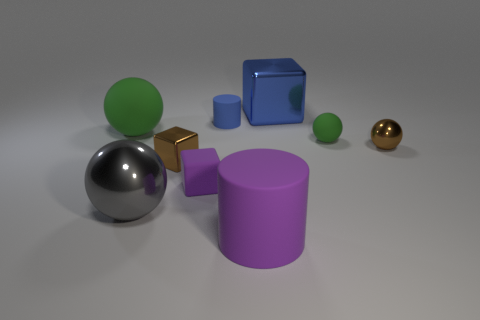Subtract all small rubber blocks. How many blocks are left? 2 Subtract all gray balls. How many balls are left? 3 Subtract 1 cylinders. How many cylinders are left? 1 Subtract all cylinders. How many objects are left? 7 Add 9 tiny matte cubes. How many tiny matte cubes exist? 10 Subtract 2 green spheres. How many objects are left? 7 Subtract all purple balls. Subtract all brown cubes. How many balls are left? 4 Subtract all cyan cubes. How many red spheres are left? 0 Subtract all rubber cubes. Subtract all large brown metal cylinders. How many objects are left? 8 Add 9 big metal spheres. How many big metal spheres are left? 10 